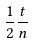<formula> <loc_0><loc_0><loc_500><loc_500>\frac { 1 } { 2 } \frac { t } { n }</formula> 